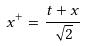<formula> <loc_0><loc_0><loc_500><loc_500>x ^ { + } = \frac { t + x } { \sqrt { 2 } }</formula> 